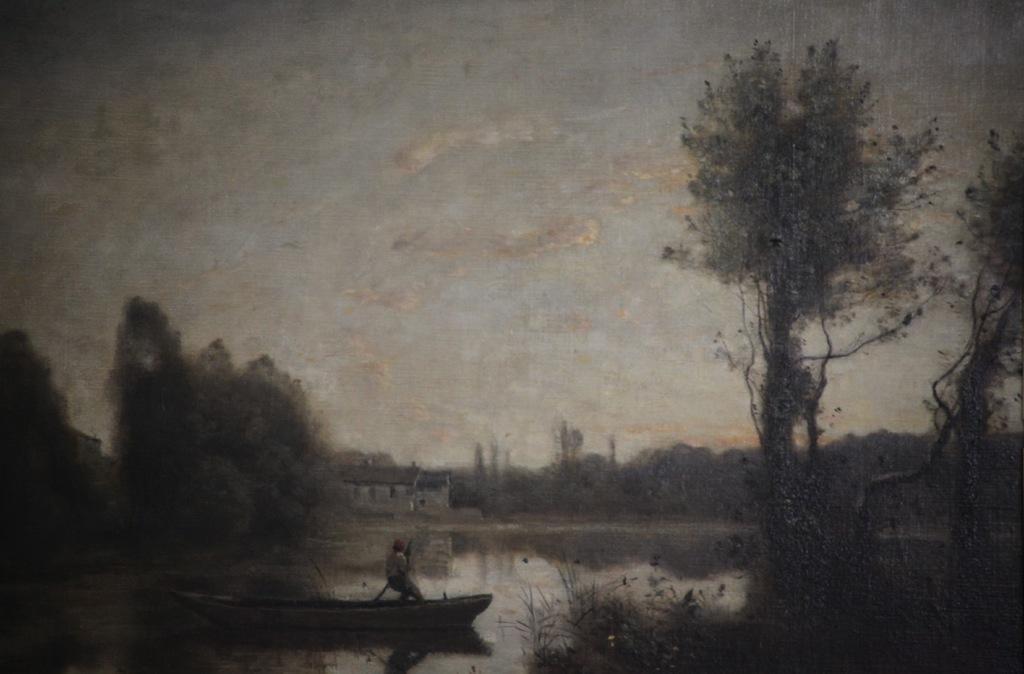What is the main subject of the image? There is a person in a boat in the image. What body of water is the person in the boat on? There is a lake in the image. What can be seen in the background of the image? There are trees surrounding the lake in the image. What is visible in the sky in the image? Clouds are visible in the sky in the image. How is the image created? The image appears to be a painting. What type of hospital can be seen in the image? There is no hospital present in the image; it features a person in a boat on a lake surrounded by trees. What kind of rail system is depicted in the image? There is no rail system present in the image; it is a painting of a person in a boat on a lake surrounded by trees. 